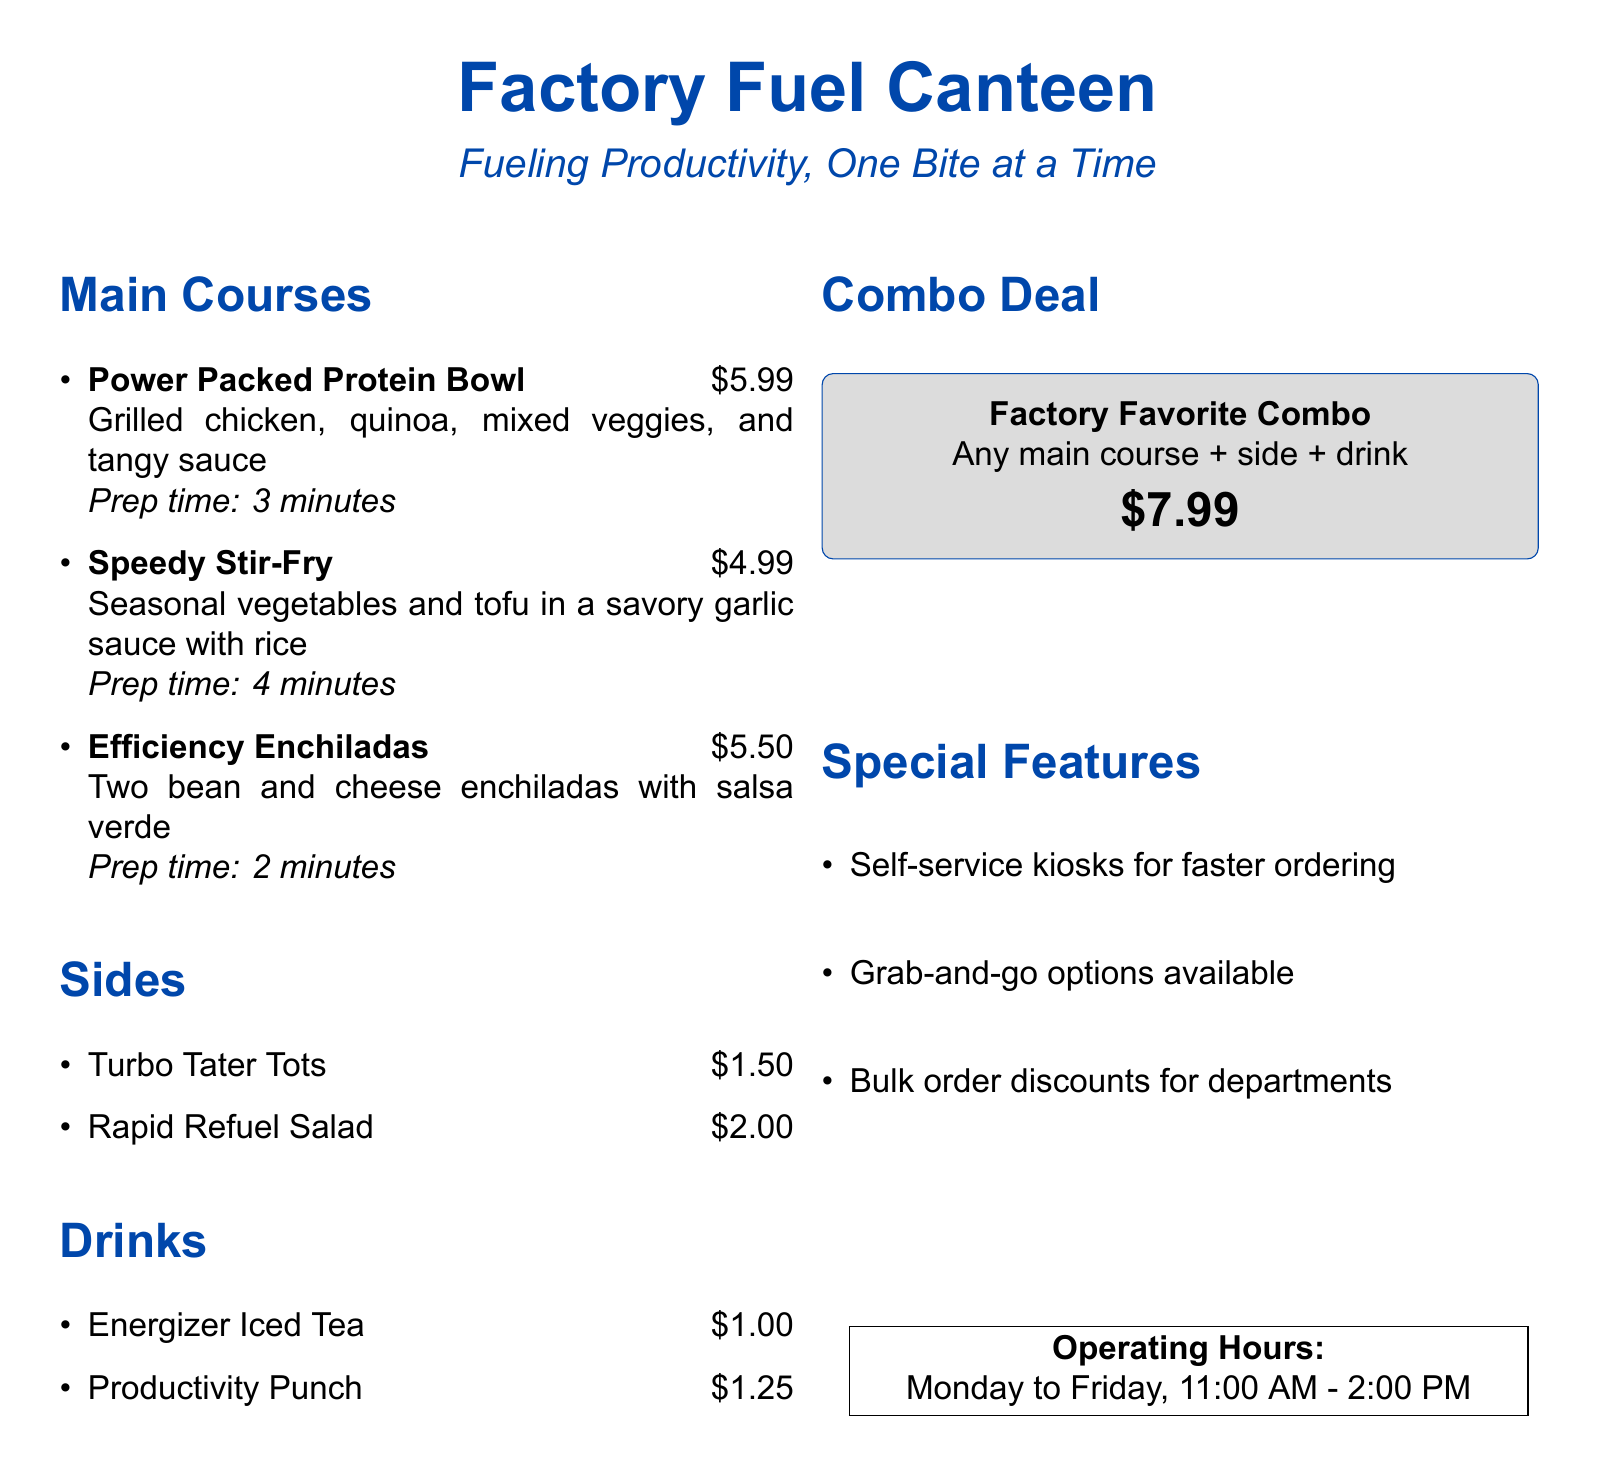what is the price of the Power Packed Protein Bowl? The document lists the price next to the dish under the main courses section.
Answer: $5.99 what is the prep time for Efficiency Enchiladas? The preparation time is mentioned directly after the dish name in the menu.
Answer: 2 minutes which drinks are available? The document includes a list of drinks under the drinks section.
Answer: Energizer Iced Tea, Productivity Punch what is included in the Factory Favorite Combo? The combo details are specified in the menu, indicating what it contains.
Answer: Any main course + side + drink what is the total cost of the Combo Deal? The Combo Deal price is provided in the menu, allowing for direct reference.
Answer: $7.99 what operating days does the canteen serve? The operating hours section mentions the days the canteen is open.
Answer: Monday to Friday how much do Turbo Tater Tots cost? The price is listed next to the side item in the menu.
Answer: $1.50 what feature is mentioned to expedite ordering? The special features section outlines ways to improve service efficiency.
Answer: Self-service kiosks is there a discount for bulk orders? The special features section indicates options for larger orders.
Answer: Yes 